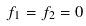<formula> <loc_0><loc_0><loc_500><loc_500>f _ { 1 } = f _ { 2 } = 0</formula> 